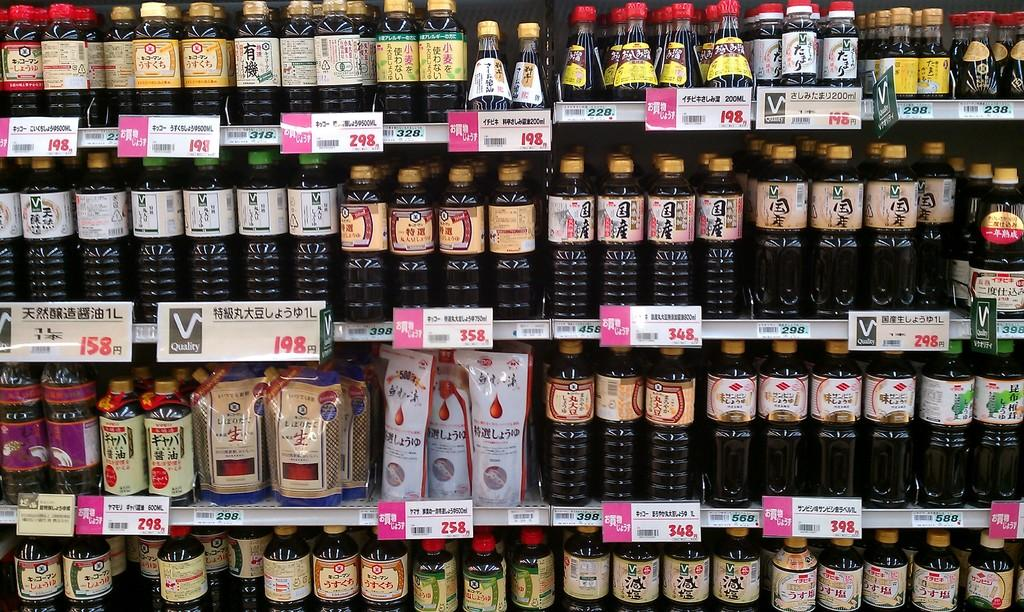Provide a one-sentence caption for the provided image. A selection of beverages at a store shows a few different options for 198. 